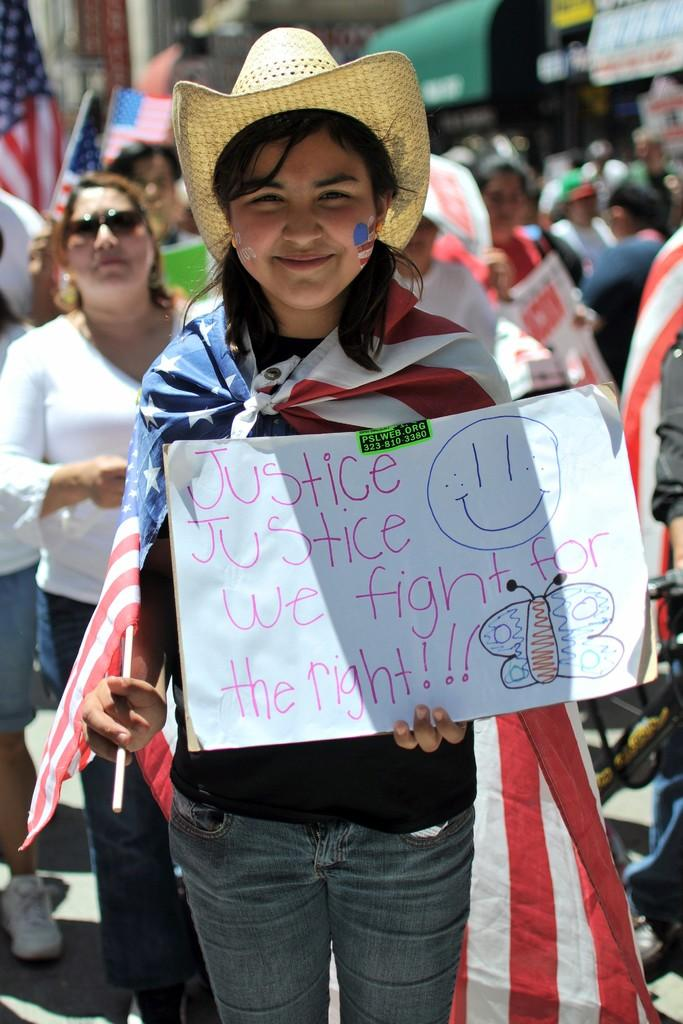What is the woman in the image doing? The woman is standing in the image and holding a poster. Where is the woman located in the image? The woman is in the middle of the image. What can be seen in the background of the image? There is a crowd visible in the background of the image. What is the woman's neck made of in the image? There is no information about the woman's neck in the image, so it cannot be determined what it is made of. 